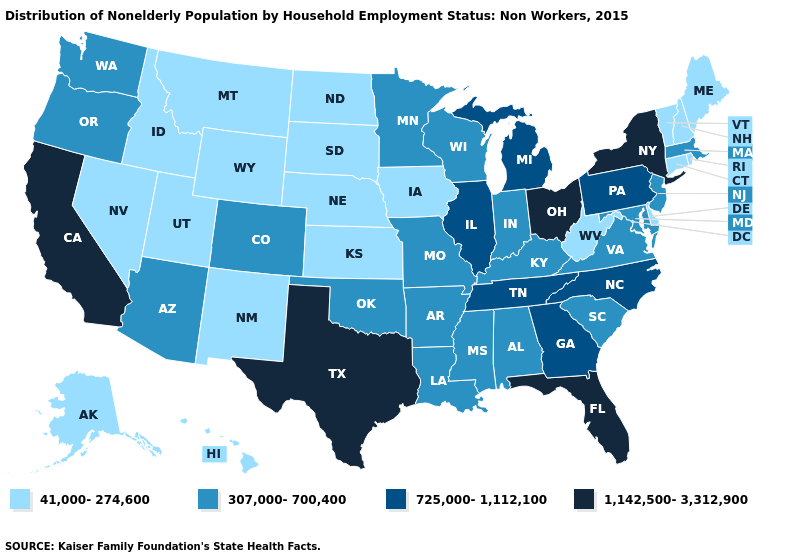Name the states that have a value in the range 725,000-1,112,100?
Be succinct. Georgia, Illinois, Michigan, North Carolina, Pennsylvania, Tennessee. Does North Dakota have the lowest value in the MidWest?
Be succinct. Yes. What is the lowest value in states that border Louisiana?
Answer briefly. 307,000-700,400. Does Ohio have the highest value in the MidWest?
Quick response, please. Yes. Does Ohio have the same value as Texas?
Write a very short answer. Yes. Does Massachusetts have a higher value than Iowa?
Give a very brief answer. Yes. Name the states that have a value in the range 725,000-1,112,100?
Write a very short answer. Georgia, Illinois, Michigan, North Carolina, Pennsylvania, Tennessee. Does the first symbol in the legend represent the smallest category?
Keep it brief. Yes. Is the legend a continuous bar?
Answer briefly. No. Does Montana have the same value as Alaska?
Concise answer only. Yes. Which states have the highest value in the USA?
Quick response, please. California, Florida, New York, Ohio, Texas. Does the first symbol in the legend represent the smallest category?
Be succinct. Yes. Among the states that border New York , does Connecticut have the highest value?
Short answer required. No. What is the lowest value in the MidWest?
Concise answer only. 41,000-274,600. Which states have the lowest value in the USA?
Write a very short answer. Alaska, Connecticut, Delaware, Hawaii, Idaho, Iowa, Kansas, Maine, Montana, Nebraska, Nevada, New Hampshire, New Mexico, North Dakota, Rhode Island, South Dakota, Utah, Vermont, West Virginia, Wyoming. 